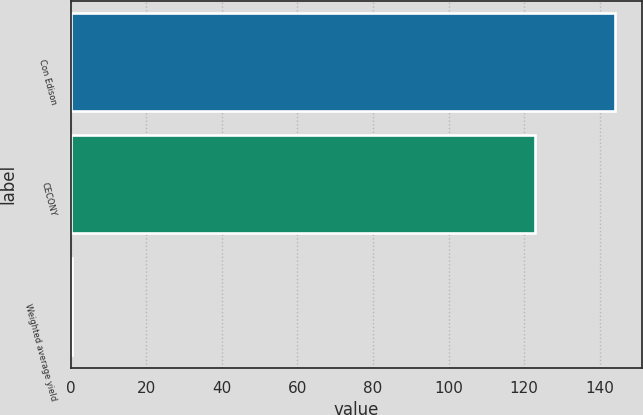Convert chart to OTSL. <chart><loc_0><loc_0><loc_500><loc_500><bar_chart><fcel>Con Edison<fcel>CECONY<fcel>Weighted average yield<nl><fcel>144<fcel>123<fcel>0.3<nl></chart> 